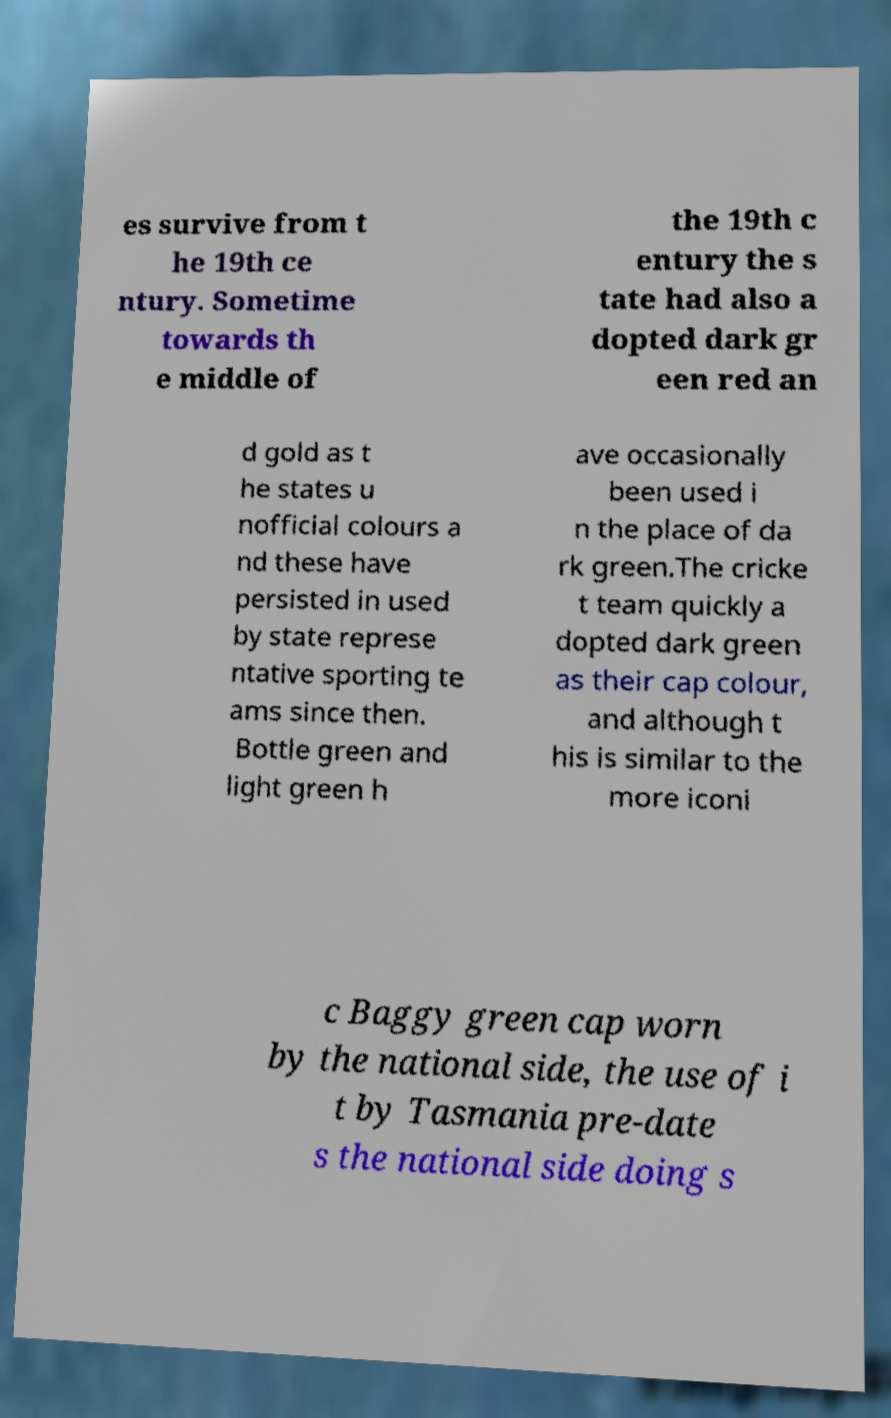Can you read and provide the text displayed in the image?This photo seems to have some interesting text. Can you extract and type it out for me? es survive from t he 19th ce ntury. Sometime towards th e middle of the 19th c entury the s tate had also a dopted dark gr een red an d gold as t he states u nofficial colours a nd these have persisted in used by state represe ntative sporting te ams since then. Bottle green and light green h ave occasionally been used i n the place of da rk green.The cricke t team quickly a dopted dark green as their cap colour, and although t his is similar to the more iconi c Baggy green cap worn by the national side, the use of i t by Tasmania pre-date s the national side doing s 